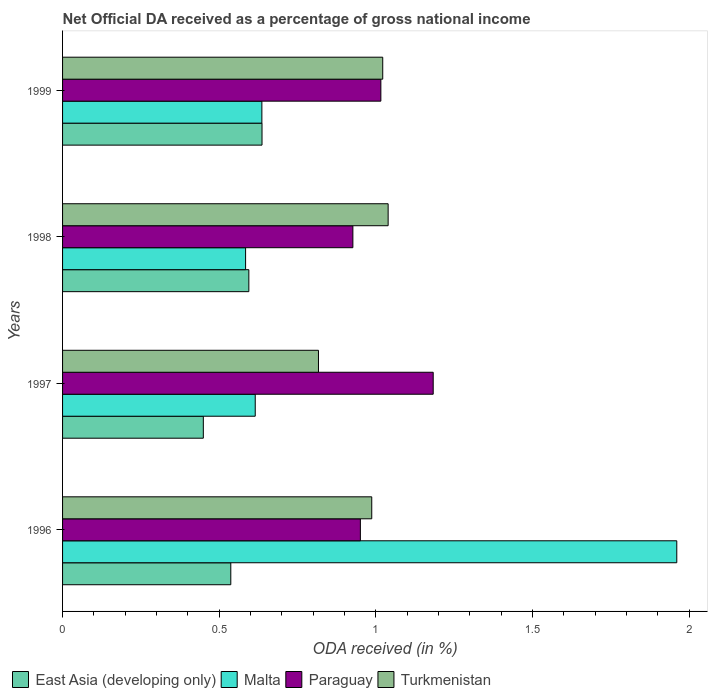How many different coloured bars are there?
Provide a short and direct response. 4. How many groups of bars are there?
Make the answer very short. 4. How many bars are there on the 1st tick from the top?
Give a very brief answer. 4. How many bars are there on the 3rd tick from the bottom?
Keep it short and to the point. 4. What is the net official DA received in Turkmenistan in 1996?
Make the answer very short. 0.99. Across all years, what is the maximum net official DA received in Turkmenistan?
Give a very brief answer. 1.04. Across all years, what is the minimum net official DA received in Turkmenistan?
Make the answer very short. 0.82. What is the total net official DA received in East Asia (developing only) in the graph?
Provide a short and direct response. 2.22. What is the difference between the net official DA received in East Asia (developing only) in 1998 and that in 1999?
Your answer should be very brief. -0.04. What is the difference between the net official DA received in Paraguay in 1996 and the net official DA received in Turkmenistan in 1997?
Give a very brief answer. 0.13. What is the average net official DA received in Turkmenistan per year?
Your answer should be compact. 0.97. In the year 1996, what is the difference between the net official DA received in East Asia (developing only) and net official DA received in Turkmenistan?
Provide a short and direct response. -0.45. What is the ratio of the net official DA received in Paraguay in 1996 to that in 1999?
Your answer should be compact. 0.94. Is the net official DA received in Turkmenistan in 1997 less than that in 1998?
Provide a succinct answer. Yes. What is the difference between the highest and the second highest net official DA received in East Asia (developing only)?
Your response must be concise. 0.04. What is the difference between the highest and the lowest net official DA received in Malta?
Make the answer very short. 1.38. What does the 4th bar from the top in 1997 represents?
Keep it short and to the point. East Asia (developing only). What does the 1st bar from the bottom in 1996 represents?
Keep it short and to the point. East Asia (developing only). Is it the case that in every year, the sum of the net official DA received in Paraguay and net official DA received in East Asia (developing only) is greater than the net official DA received in Turkmenistan?
Make the answer very short. Yes. How many bars are there?
Offer a very short reply. 16. Are all the bars in the graph horizontal?
Your answer should be very brief. Yes. What is the difference between two consecutive major ticks on the X-axis?
Ensure brevity in your answer.  0.5. Does the graph contain any zero values?
Provide a succinct answer. No. Where does the legend appear in the graph?
Keep it short and to the point. Bottom left. How many legend labels are there?
Provide a succinct answer. 4. What is the title of the graph?
Give a very brief answer. Net Official DA received as a percentage of gross national income. Does "New Caledonia" appear as one of the legend labels in the graph?
Your answer should be compact. No. What is the label or title of the X-axis?
Give a very brief answer. ODA received (in %). What is the label or title of the Y-axis?
Ensure brevity in your answer.  Years. What is the ODA received (in %) of East Asia (developing only) in 1996?
Your answer should be compact. 0.54. What is the ODA received (in %) of Malta in 1996?
Offer a terse response. 1.96. What is the ODA received (in %) in Paraguay in 1996?
Your answer should be compact. 0.95. What is the ODA received (in %) in Turkmenistan in 1996?
Ensure brevity in your answer.  0.99. What is the ODA received (in %) of East Asia (developing only) in 1997?
Keep it short and to the point. 0.45. What is the ODA received (in %) in Malta in 1997?
Your answer should be compact. 0.61. What is the ODA received (in %) of Paraguay in 1997?
Keep it short and to the point. 1.18. What is the ODA received (in %) in Turkmenistan in 1997?
Provide a short and direct response. 0.82. What is the ODA received (in %) of East Asia (developing only) in 1998?
Offer a terse response. 0.59. What is the ODA received (in %) of Malta in 1998?
Make the answer very short. 0.58. What is the ODA received (in %) of Paraguay in 1998?
Give a very brief answer. 0.93. What is the ODA received (in %) of Turkmenistan in 1998?
Keep it short and to the point. 1.04. What is the ODA received (in %) of East Asia (developing only) in 1999?
Your response must be concise. 0.64. What is the ODA received (in %) of Malta in 1999?
Ensure brevity in your answer.  0.64. What is the ODA received (in %) in Paraguay in 1999?
Offer a terse response. 1.02. What is the ODA received (in %) of Turkmenistan in 1999?
Offer a terse response. 1.02. Across all years, what is the maximum ODA received (in %) in East Asia (developing only)?
Offer a very short reply. 0.64. Across all years, what is the maximum ODA received (in %) in Malta?
Your answer should be very brief. 1.96. Across all years, what is the maximum ODA received (in %) of Paraguay?
Give a very brief answer. 1.18. Across all years, what is the maximum ODA received (in %) of Turkmenistan?
Make the answer very short. 1.04. Across all years, what is the minimum ODA received (in %) in East Asia (developing only)?
Your response must be concise. 0.45. Across all years, what is the minimum ODA received (in %) in Malta?
Offer a very short reply. 0.58. Across all years, what is the minimum ODA received (in %) of Paraguay?
Offer a terse response. 0.93. Across all years, what is the minimum ODA received (in %) in Turkmenistan?
Give a very brief answer. 0.82. What is the total ODA received (in %) in East Asia (developing only) in the graph?
Offer a very short reply. 2.22. What is the total ODA received (in %) of Malta in the graph?
Your response must be concise. 3.79. What is the total ODA received (in %) in Paraguay in the graph?
Offer a very short reply. 4.08. What is the total ODA received (in %) in Turkmenistan in the graph?
Make the answer very short. 3.86. What is the difference between the ODA received (in %) in East Asia (developing only) in 1996 and that in 1997?
Keep it short and to the point. 0.09. What is the difference between the ODA received (in %) of Malta in 1996 and that in 1997?
Provide a short and direct response. 1.35. What is the difference between the ODA received (in %) in Paraguay in 1996 and that in 1997?
Offer a very short reply. -0.23. What is the difference between the ODA received (in %) of Turkmenistan in 1996 and that in 1997?
Your answer should be very brief. 0.17. What is the difference between the ODA received (in %) in East Asia (developing only) in 1996 and that in 1998?
Provide a short and direct response. -0.06. What is the difference between the ODA received (in %) in Malta in 1996 and that in 1998?
Your answer should be compact. 1.38. What is the difference between the ODA received (in %) in Paraguay in 1996 and that in 1998?
Ensure brevity in your answer.  0.02. What is the difference between the ODA received (in %) of Turkmenistan in 1996 and that in 1998?
Provide a short and direct response. -0.05. What is the difference between the ODA received (in %) in East Asia (developing only) in 1996 and that in 1999?
Provide a succinct answer. -0.1. What is the difference between the ODA received (in %) in Malta in 1996 and that in 1999?
Your response must be concise. 1.32. What is the difference between the ODA received (in %) of Paraguay in 1996 and that in 1999?
Keep it short and to the point. -0.07. What is the difference between the ODA received (in %) of Turkmenistan in 1996 and that in 1999?
Your answer should be very brief. -0.04. What is the difference between the ODA received (in %) in East Asia (developing only) in 1997 and that in 1998?
Give a very brief answer. -0.15. What is the difference between the ODA received (in %) of Malta in 1997 and that in 1998?
Your answer should be very brief. 0.03. What is the difference between the ODA received (in %) of Paraguay in 1997 and that in 1998?
Ensure brevity in your answer.  0.26. What is the difference between the ODA received (in %) in Turkmenistan in 1997 and that in 1998?
Keep it short and to the point. -0.22. What is the difference between the ODA received (in %) of East Asia (developing only) in 1997 and that in 1999?
Your answer should be very brief. -0.19. What is the difference between the ODA received (in %) in Malta in 1997 and that in 1999?
Provide a short and direct response. -0.02. What is the difference between the ODA received (in %) of Paraguay in 1997 and that in 1999?
Make the answer very short. 0.17. What is the difference between the ODA received (in %) of Turkmenistan in 1997 and that in 1999?
Make the answer very short. -0.21. What is the difference between the ODA received (in %) of East Asia (developing only) in 1998 and that in 1999?
Your answer should be compact. -0.04. What is the difference between the ODA received (in %) in Malta in 1998 and that in 1999?
Provide a succinct answer. -0.05. What is the difference between the ODA received (in %) in Paraguay in 1998 and that in 1999?
Ensure brevity in your answer.  -0.09. What is the difference between the ODA received (in %) of Turkmenistan in 1998 and that in 1999?
Ensure brevity in your answer.  0.02. What is the difference between the ODA received (in %) in East Asia (developing only) in 1996 and the ODA received (in %) in Malta in 1997?
Your answer should be compact. -0.08. What is the difference between the ODA received (in %) in East Asia (developing only) in 1996 and the ODA received (in %) in Paraguay in 1997?
Offer a very short reply. -0.65. What is the difference between the ODA received (in %) of East Asia (developing only) in 1996 and the ODA received (in %) of Turkmenistan in 1997?
Provide a succinct answer. -0.28. What is the difference between the ODA received (in %) of Malta in 1996 and the ODA received (in %) of Paraguay in 1997?
Keep it short and to the point. 0.78. What is the difference between the ODA received (in %) of Malta in 1996 and the ODA received (in %) of Turkmenistan in 1997?
Provide a succinct answer. 1.14. What is the difference between the ODA received (in %) in Paraguay in 1996 and the ODA received (in %) in Turkmenistan in 1997?
Offer a terse response. 0.13. What is the difference between the ODA received (in %) of East Asia (developing only) in 1996 and the ODA received (in %) of Malta in 1998?
Your answer should be very brief. -0.05. What is the difference between the ODA received (in %) of East Asia (developing only) in 1996 and the ODA received (in %) of Paraguay in 1998?
Provide a short and direct response. -0.39. What is the difference between the ODA received (in %) of East Asia (developing only) in 1996 and the ODA received (in %) of Turkmenistan in 1998?
Make the answer very short. -0.5. What is the difference between the ODA received (in %) in Malta in 1996 and the ODA received (in %) in Paraguay in 1998?
Provide a succinct answer. 1.03. What is the difference between the ODA received (in %) of Malta in 1996 and the ODA received (in %) of Turkmenistan in 1998?
Offer a very short reply. 0.92. What is the difference between the ODA received (in %) of Paraguay in 1996 and the ODA received (in %) of Turkmenistan in 1998?
Make the answer very short. -0.09. What is the difference between the ODA received (in %) in East Asia (developing only) in 1996 and the ODA received (in %) in Malta in 1999?
Make the answer very short. -0.1. What is the difference between the ODA received (in %) in East Asia (developing only) in 1996 and the ODA received (in %) in Paraguay in 1999?
Provide a succinct answer. -0.48. What is the difference between the ODA received (in %) of East Asia (developing only) in 1996 and the ODA received (in %) of Turkmenistan in 1999?
Offer a very short reply. -0.48. What is the difference between the ODA received (in %) in Malta in 1996 and the ODA received (in %) in Paraguay in 1999?
Make the answer very short. 0.94. What is the difference between the ODA received (in %) in Malta in 1996 and the ODA received (in %) in Turkmenistan in 1999?
Keep it short and to the point. 0.94. What is the difference between the ODA received (in %) in Paraguay in 1996 and the ODA received (in %) in Turkmenistan in 1999?
Provide a succinct answer. -0.07. What is the difference between the ODA received (in %) of East Asia (developing only) in 1997 and the ODA received (in %) of Malta in 1998?
Make the answer very short. -0.13. What is the difference between the ODA received (in %) of East Asia (developing only) in 1997 and the ODA received (in %) of Paraguay in 1998?
Offer a terse response. -0.48. What is the difference between the ODA received (in %) of East Asia (developing only) in 1997 and the ODA received (in %) of Turkmenistan in 1998?
Your answer should be very brief. -0.59. What is the difference between the ODA received (in %) of Malta in 1997 and the ODA received (in %) of Paraguay in 1998?
Provide a short and direct response. -0.31. What is the difference between the ODA received (in %) in Malta in 1997 and the ODA received (in %) in Turkmenistan in 1998?
Give a very brief answer. -0.42. What is the difference between the ODA received (in %) in Paraguay in 1997 and the ODA received (in %) in Turkmenistan in 1998?
Provide a succinct answer. 0.14. What is the difference between the ODA received (in %) of East Asia (developing only) in 1997 and the ODA received (in %) of Malta in 1999?
Give a very brief answer. -0.19. What is the difference between the ODA received (in %) of East Asia (developing only) in 1997 and the ODA received (in %) of Paraguay in 1999?
Provide a succinct answer. -0.57. What is the difference between the ODA received (in %) in East Asia (developing only) in 1997 and the ODA received (in %) in Turkmenistan in 1999?
Ensure brevity in your answer.  -0.57. What is the difference between the ODA received (in %) in Malta in 1997 and the ODA received (in %) in Paraguay in 1999?
Provide a succinct answer. -0.4. What is the difference between the ODA received (in %) in Malta in 1997 and the ODA received (in %) in Turkmenistan in 1999?
Your answer should be very brief. -0.41. What is the difference between the ODA received (in %) in Paraguay in 1997 and the ODA received (in %) in Turkmenistan in 1999?
Give a very brief answer. 0.16. What is the difference between the ODA received (in %) of East Asia (developing only) in 1998 and the ODA received (in %) of Malta in 1999?
Your answer should be compact. -0.04. What is the difference between the ODA received (in %) in East Asia (developing only) in 1998 and the ODA received (in %) in Paraguay in 1999?
Make the answer very short. -0.42. What is the difference between the ODA received (in %) of East Asia (developing only) in 1998 and the ODA received (in %) of Turkmenistan in 1999?
Your answer should be compact. -0.43. What is the difference between the ODA received (in %) of Malta in 1998 and the ODA received (in %) of Paraguay in 1999?
Make the answer very short. -0.43. What is the difference between the ODA received (in %) in Malta in 1998 and the ODA received (in %) in Turkmenistan in 1999?
Your answer should be compact. -0.44. What is the difference between the ODA received (in %) in Paraguay in 1998 and the ODA received (in %) in Turkmenistan in 1999?
Your answer should be compact. -0.1. What is the average ODA received (in %) of East Asia (developing only) per year?
Give a very brief answer. 0.55. What is the average ODA received (in %) in Malta per year?
Your answer should be very brief. 0.95. What is the average ODA received (in %) in Paraguay per year?
Keep it short and to the point. 1.02. In the year 1996, what is the difference between the ODA received (in %) of East Asia (developing only) and ODA received (in %) of Malta?
Offer a very short reply. -1.42. In the year 1996, what is the difference between the ODA received (in %) in East Asia (developing only) and ODA received (in %) in Paraguay?
Your answer should be very brief. -0.41. In the year 1996, what is the difference between the ODA received (in %) in East Asia (developing only) and ODA received (in %) in Turkmenistan?
Keep it short and to the point. -0.45. In the year 1996, what is the difference between the ODA received (in %) of Malta and ODA received (in %) of Paraguay?
Offer a terse response. 1.01. In the year 1996, what is the difference between the ODA received (in %) in Malta and ODA received (in %) in Turkmenistan?
Offer a very short reply. 0.97. In the year 1996, what is the difference between the ODA received (in %) of Paraguay and ODA received (in %) of Turkmenistan?
Keep it short and to the point. -0.04. In the year 1997, what is the difference between the ODA received (in %) of East Asia (developing only) and ODA received (in %) of Malta?
Offer a very short reply. -0.17. In the year 1997, what is the difference between the ODA received (in %) of East Asia (developing only) and ODA received (in %) of Paraguay?
Your answer should be very brief. -0.73. In the year 1997, what is the difference between the ODA received (in %) of East Asia (developing only) and ODA received (in %) of Turkmenistan?
Your answer should be very brief. -0.37. In the year 1997, what is the difference between the ODA received (in %) in Malta and ODA received (in %) in Paraguay?
Your answer should be very brief. -0.57. In the year 1997, what is the difference between the ODA received (in %) in Malta and ODA received (in %) in Turkmenistan?
Offer a very short reply. -0.2. In the year 1997, what is the difference between the ODA received (in %) in Paraguay and ODA received (in %) in Turkmenistan?
Offer a terse response. 0.37. In the year 1998, what is the difference between the ODA received (in %) in East Asia (developing only) and ODA received (in %) in Malta?
Provide a succinct answer. 0.01. In the year 1998, what is the difference between the ODA received (in %) of East Asia (developing only) and ODA received (in %) of Paraguay?
Provide a succinct answer. -0.33. In the year 1998, what is the difference between the ODA received (in %) of East Asia (developing only) and ODA received (in %) of Turkmenistan?
Offer a very short reply. -0.44. In the year 1998, what is the difference between the ODA received (in %) of Malta and ODA received (in %) of Paraguay?
Provide a short and direct response. -0.34. In the year 1998, what is the difference between the ODA received (in %) in Malta and ODA received (in %) in Turkmenistan?
Give a very brief answer. -0.45. In the year 1998, what is the difference between the ODA received (in %) of Paraguay and ODA received (in %) of Turkmenistan?
Your answer should be compact. -0.11. In the year 1999, what is the difference between the ODA received (in %) of East Asia (developing only) and ODA received (in %) of Malta?
Provide a short and direct response. 0. In the year 1999, what is the difference between the ODA received (in %) of East Asia (developing only) and ODA received (in %) of Paraguay?
Give a very brief answer. -0.38. In the year 1999, what is the difference between the ODA received (in %) of East Asia (developing only) and ODA received (in %) of Turkmenistan?
Provide a succinct answer. -0.39. In the year 1999, what is the difference between the ODA received (in %) in Malta and ODA received (in %) in Paraguay?
Ensure brevity in your answer.  -0.38. In the year 1999, what is the difference between the ODA received (in %) in Malta and ODA received (in %) in Turkmenistan?
Your answer should be compact. -0.39. In the year 1999, what is the difference between the ODA received (in %) of Paraguay and ODA received (in %) of Turkmenistan?
Your answer should be very brief. -0.01. What is the ratio of the ODA received (in %) in East Asia (developing only) in 1996 to that in 1997?
Make the answer very short. 1.2. What is the ratio of the ODA received (in %) of Malta in 1996 to that in 1997?
Your response must be concise. 3.19. What is the ratio of the ODA received (in %) in Paraguay in 1996 to that in 1997?
Make the answer very short. 0.8. What is the ratio of the ODA received (in %) in Turkmenistan in 1996 to that in 1997?
Keep it short and to the point. 1.21. What is the ratio of the ODA received (in %) in East Asia (developing only) in 1996 to that in 1998?
Keep it short and to the point. 0.9. What is the ratio of the ODA received (in %) in Malta in 1996 to that in 1998?
Your response must be concise. 3.36. What is the ratio of the ODA received (in %) in Paraguay in 1996 to that in 1998?
Your answer should be very brief. 1.03. What is the ratio of the ODA received (in %) in Turkmenistan in 1996 to that in 1998?
Your answer should be very brief. 0.95. What is the ratio of the ODA received (in %) of East Asia (developing only) in 1996 to that in 1999?
Your answer should be very brief. 0.84. What is the ratio of the ODA received (in %) of Malta in 1996 to that in 1999?
Offer a terse response. 3.08. What is the ratio of the ODA received (in %) of Paraguay in 1996 to that in 1999?
Your response must be concise. 0.94. What is the ratio of the ODA received (in %) of Turkmenistan in 1996 to that in 1999?
Your answer should be very brief. 0.97. What is the ratio of the ODA received (in %) of East Asia (developing only) in 1997 to that in 1998?
Keep it short and to the point. 0.76. What is the ratio of the ODA received (in %) in Malta in 1997 to that in 1998?
Ensure brevity in your answer.  1.05. What is the ratio of the ODA received (in %) of Paraguay in 1997 to that in 1998?
Provide a short and direct response. 1.28. What is the ratio of the ODA received (in %) in Turkmenistan in 1997 to that in 1998?
Make the answer very short. 0.79. What is the ratio of the ODA received (in %) of East Asia (developing only) in 1997 to that in 1999?
Your response must be concise. 0.71. What is the ratio of the ODA received (in %) of Malta in 1997 to that in 1999?
Give a very brief answer. 0.97. What is the ratio of the ODA received (in %) in Paraguay in 1997 to that in 1999?
Make the answer very short. 1.16. What is the ratio of the ODA received (in %) in Turkmenistan in 1997 to that in 1999?
Give a very brief answer. 0.8. What is the ratio of the ODA received (in %) in East Asia (developing only) in 1998 to that in 1999?
Your answer should be compact. 0.93. What is the ratio of the ODA received (in %) in Malta in 1998 to that in 1999?
Your answer should be compact. 0.92. What is the ratio of the ODA received (in %) of Paraguay in 1998 to that in 1999?
Give a very brief answer. 0.91. What is the ratio of the ODA received (in %) in Turkmenistan in 1998 to that in 1999?
Your answer should be very brief. 1.02. What is the difference between the highest and the second highest ODA received (in %) in East Asia (developing only)?
Give a very brief answer. 0.04. What is the difference between the highest and the second highest ODA received (in %) of Malta?
Your answer should be compact. 1.32. What is the difference between the highest and the second highest ODA received (in %) of Paraguay?
Your answer should be very brief. 0.17. What is the difference between the highest and the second highest ODA received (in %) in Turkmenistan?
Offer a terse response. 0.02. What is the difference between the highest and the lowest ODA received (in %) of East Asia (developing only)?
Give a very brief answer. 0.19. What is the difference between the highest and the lowest ODA received (in %) of Malta?
Ensure brevity in your answer.  1.38. What is the difference between the highest and the lowest ODA received (in %) of Paraguay?
Keep it short and to the point. 0.26. What is the difference between the highest and the lowest ODA received (in %) in Turkmenistan?
Offer a terse response. 0.22. 